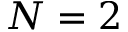<formula> <loc_0><loc_0><loc_500><loc_500>N = 2</formula> 